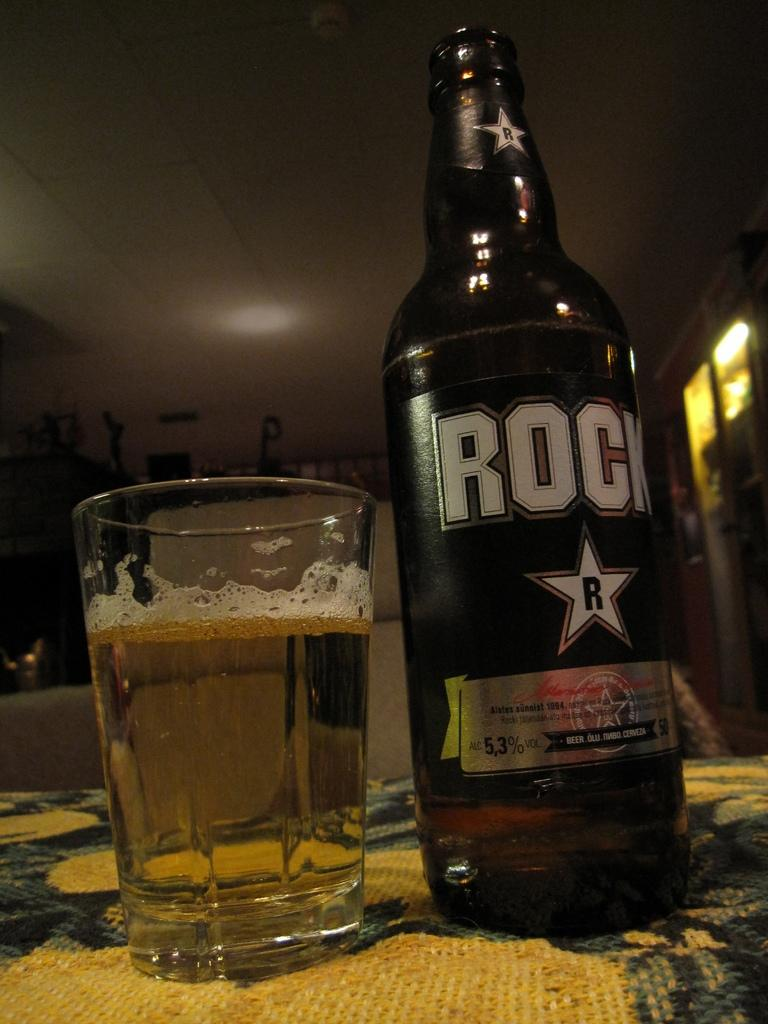What is the main object on the table in the image? There is an alcohol bottle in the image. What is the bottle's contents being used for? The contents of the bottle are in a glass, suggesting that they are being consumed. Where is the table located in the image? The table is in front of a wall, which can be seen in the background of the image. What can be seen in the background of the image besides the wall? There are lights visible in the background of the image. What type of nail is being used to open the alcohol bottle in the image? There is no nail present in the image, and the bottle is not being opened. 